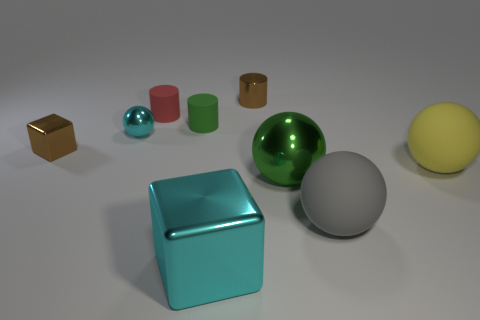Is the small block the same color as the tiny ball?
Keep it short and to the point. No. There is a gray object that is the same size as the cyan metallic block; what is its shape?
Make the answer very short. Sphere. There is a large cyan thing that is right of the small red matte object; are there any large gray spheres on the left side of it?
Ensure brevity in your answer.  No. How many small things are blocks or green spheres?
Ensure brevity in your answer.  1. Is there a green shiny sphere that has the same size as the cyan metal sphere?
Give a very brief answer. No. How many shiny things are either brown cylinders or brown objects?
Offer a very short reply. 2. The small shiny object that is the same color as the small block is what shape?
Your answer should be very brief. Cylinder. How many balls are there?
Provide a succinct answer. 4. Is the green thing right of the small brown metal cylinder made of the same material as the cyan thing that is in front of the yellow rubber object?
Your answer should be compact. Yes. What is the size of the ball that is made of the same material as the large green object?
Offer a very short reply. Small. 